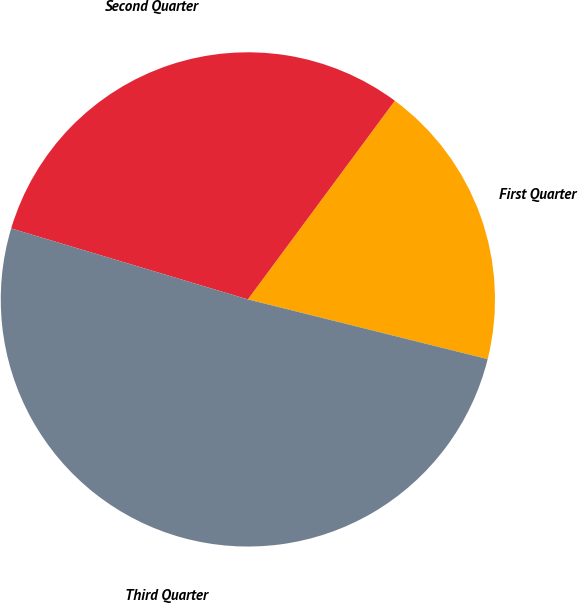Convert chart. <chart><loc_0><loc_0><loc_500><loc_500><pie_chart><fcel>First Quarter<fcel>Second Quarter<fcel>Third Quarter<nl><fcel>18.75%<fcel>30.5%<fcel>50.75%<nl></chart> 